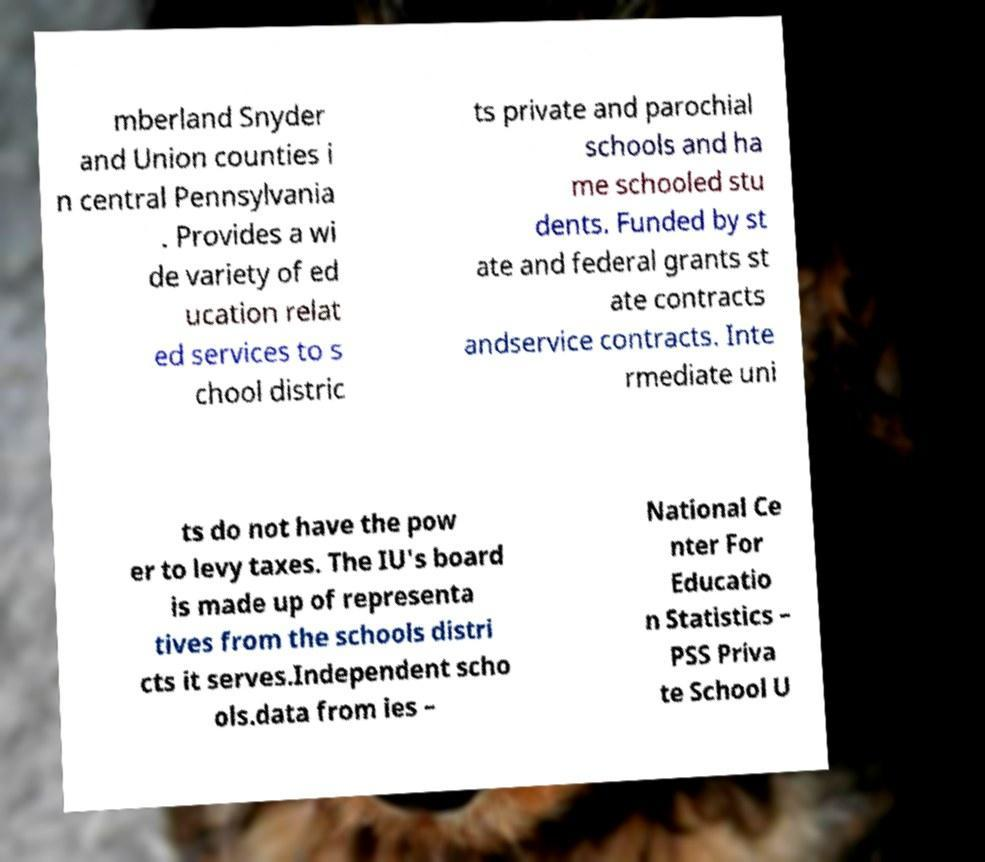Please identify and transcribe the text found in this image. mberland Snyder and Union counties i n central Pennsylvania . Provides a wi de variety of ed ucation relat ed services to s chool distric ts private and parochial schools and ha me schooled stu dents. Funded by st ate and federal grants st ate contracts andservice contracts. Inte rmediate uni ts do not have the pow er to levy taxes. The IU's board is made up of representa tives from the schools distri cts it serves.Independent scho ols.data from ies – National Ce nter For Educatio n Statistics – PSS Priva te School U 